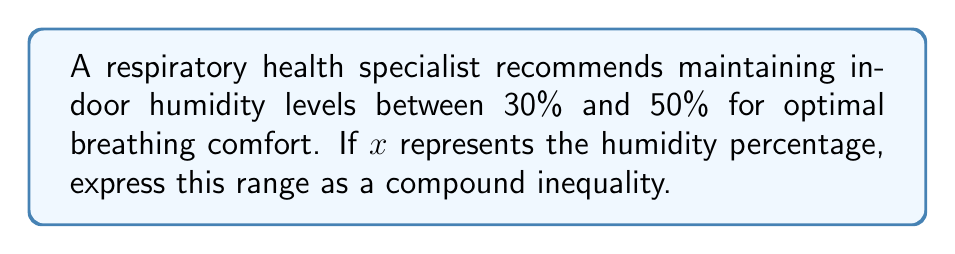Show me your answer to this math problem. To express the recommended humidity range as a compound inequality, we need to represent both the lower and upper bounds of the range.

Step 1: Identify the lower bound
The lower bound of the humidity range is 30%.
$x \geq 30$

Step 2: Identify the upper bound
The upper bound of the humidity range is 50%.
$x \leq 50$

Step 3: Combine the two inequalities
Since we want $x$ to be greater than or equal to 30% AND less than or equal to 50%, we use the "and" operator, which is represented by the $\land$ symbol in formal logic notation.

$30 \leq x \leq 50$

This compound inequality represents all values of $x$ that are simultaneously greater than or equal to 30 and less than or equal to 50.
Answer: $30 \leq x \leq 50$ 